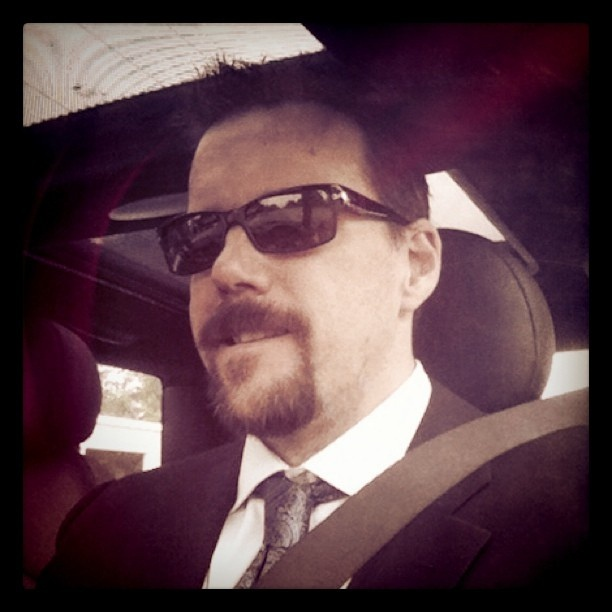Describe the objects in this image and their specific colors. I can see people in black, gray, lightgray, and purple tones and tie in black, brown, gray, darkgray, and purple tones in this image. 